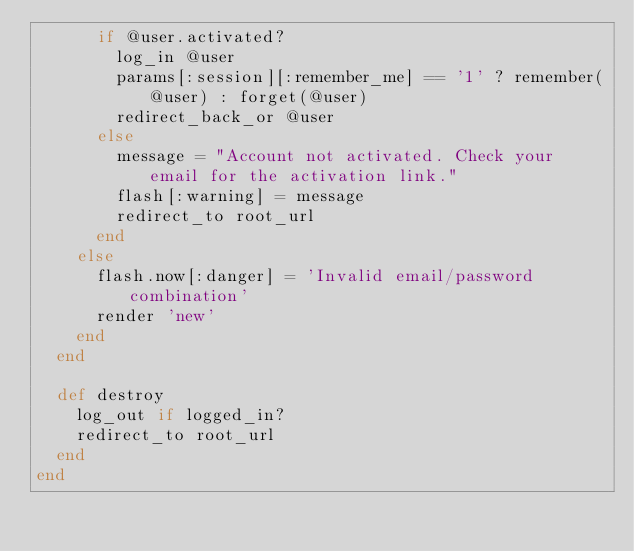<code> <loc_0><loc_0><loc_500><loc_500><_Ruby_>      if @user.activated?
        log_in @user
        params[:session][:remember_me] == '1' ? remember(@user) : forget(@user)
        redirect_back_or @user
      else
        message = "Account not activated. Check your email for the activation link."
        flash[:warning] = message
        redirect_to root_url
      end
    else
      flash.now[:danger] = 'Invalid email/password combination'
      render 'new'
    end
  end

  def destroy
    log_out if logged_in?
    redirect_to root_url
  end
end
</code> 